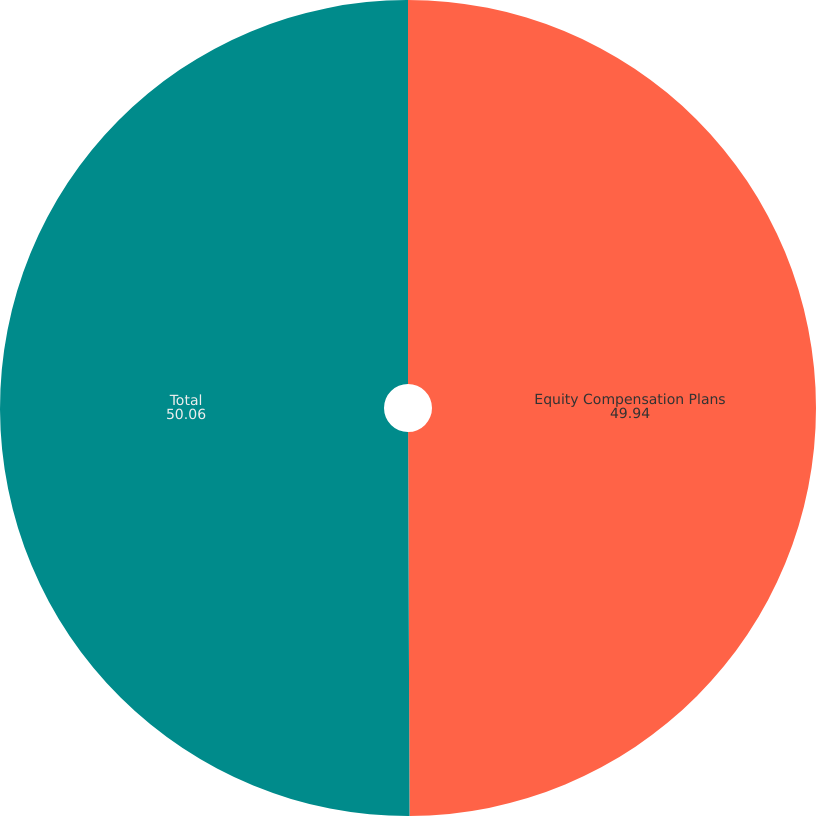Convert chart. <chart><loc_0><loc_0><loc_500><loc_500><pie_chart><fcel>Equity Compensation Plans<fcel>Total<nl><fcel>49.94%<fcel>50.06%<nl></chart> 